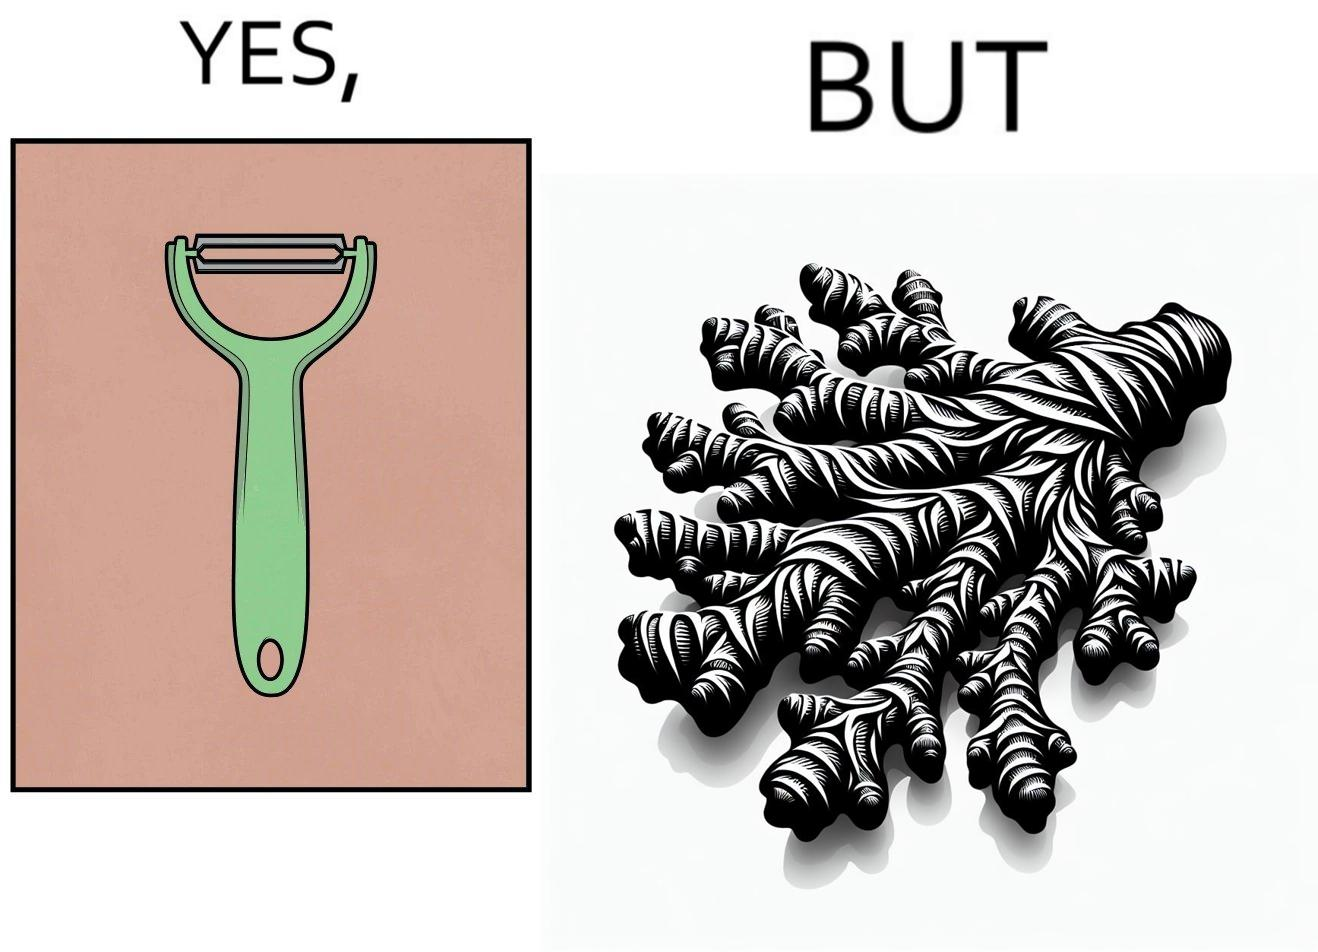What is the satirical meaning behind this image? The image is funny because it suggests that while we have peelers to peel off the skin of many different fruits and vegetables, it is useless against a ginger which has a very complicated shape. 